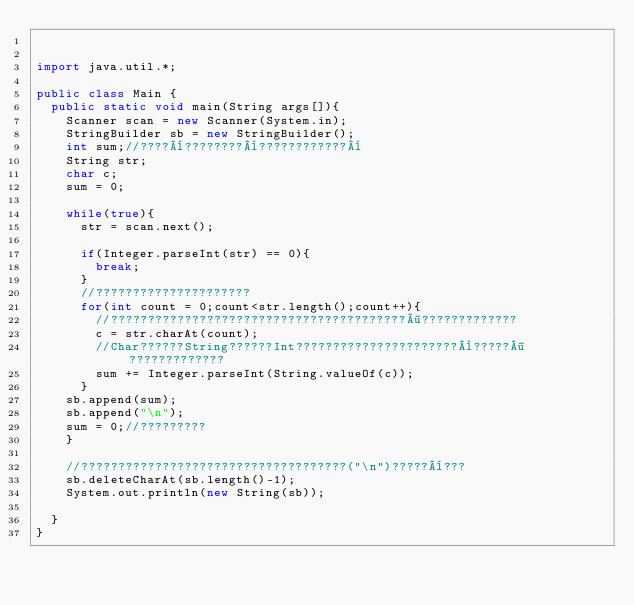<code> <loc_0><loc_0><loc_500><loc_500><_Java_>

import java.util.*;

public class Main {
	public static void main(String args[]){
		Scanner scan = new Scanner(System.in);
		StringBuilder sb = new StringBuilder();
		int sum;//????¨????????¨????????????¨
		String str;
		char c;
		sum = 0;
		
		while(true){
			str = scan.next();
			
			if(Integer.parseInt(str) == 0){
				break;
			}
			//?????????????????????
			for(int count = 0;count<str.length();count++){
				//????????????????????????????????????????¶?????????????
				c = str.charAt(count);
				//Char??????String??????Int??????????????????????¨?????¶?????????????
				sum += Integer.parseInt(String.valueOf(c));
			}
		sb.append(sum);
		sb.append("\n");
		sum = 0;//?????????
		}
		
		//????????????????????????????????????("\n")?????¨???
		sb.deleteCharAt(sb.length()-1);
		System.out.println(new String(sb));
		
	}
}</code> 